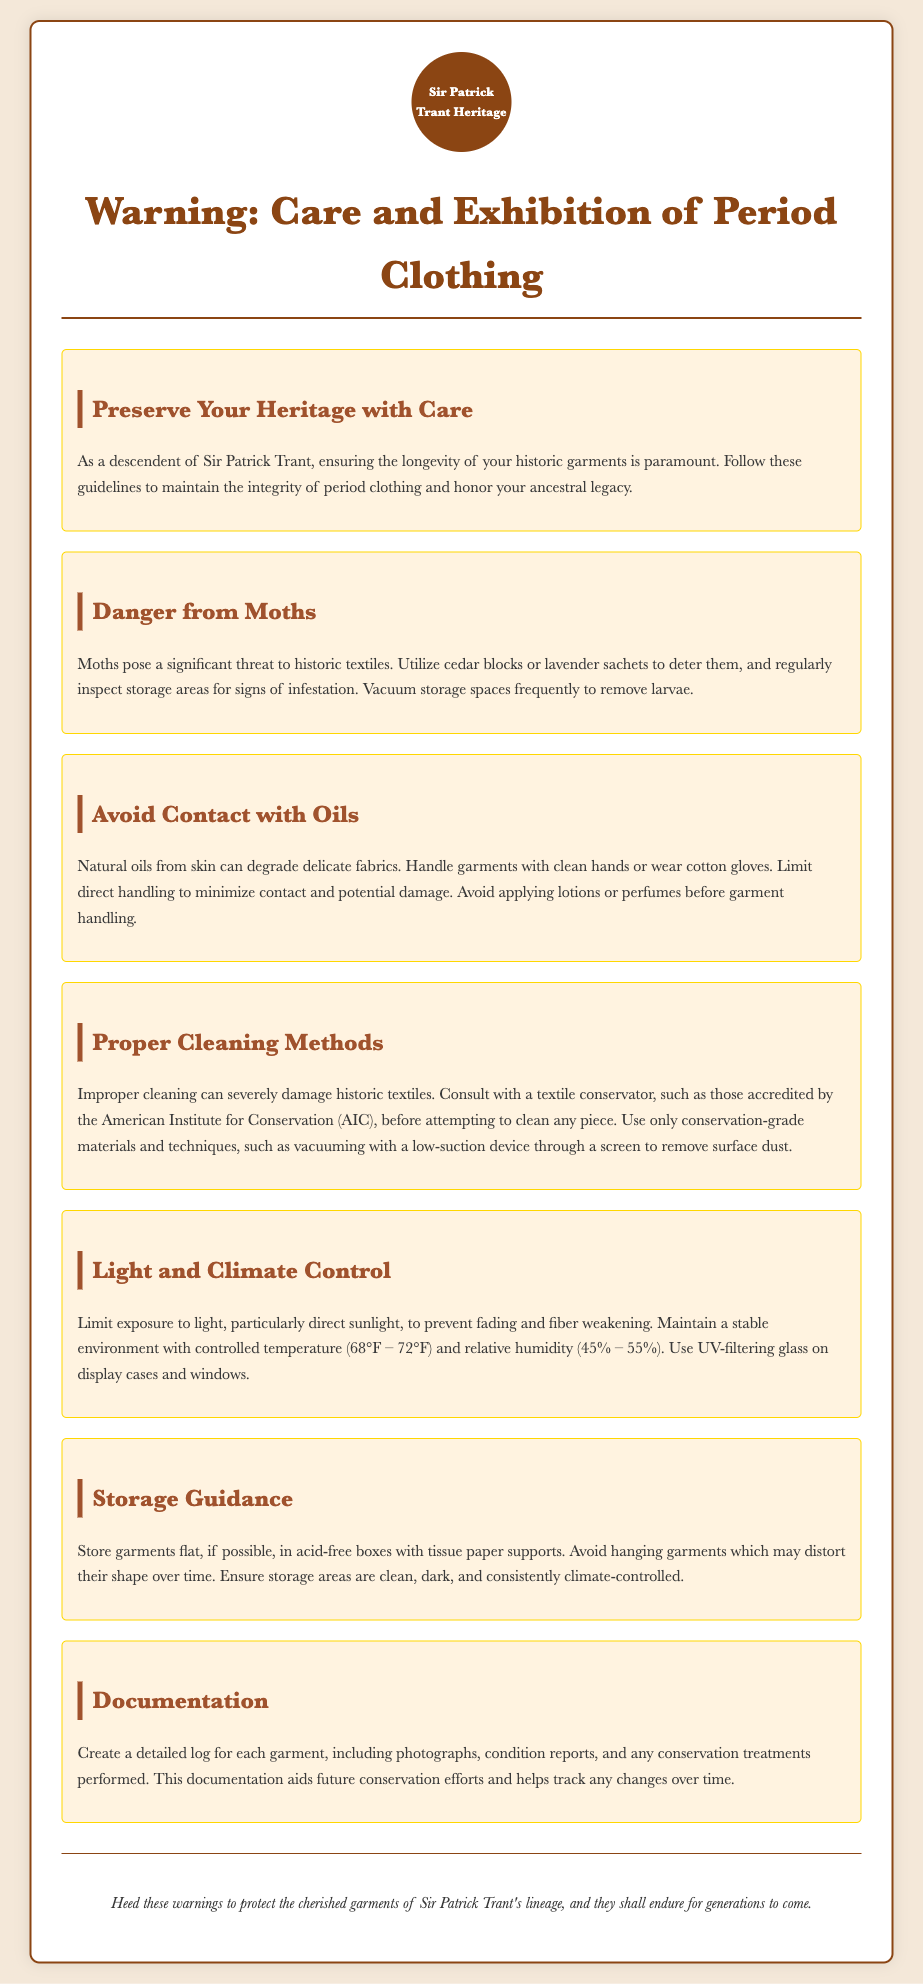What is the main purpose of the warning label? The warning label provides cautionary advice for the care and exhibition of period clothing.
Answer: Cautionary advice for the care and exhibition of period clothing What should be used to deter moths? The document suggests using cedar blocks or lavender sachets to deter moths.
Answer: Cedar blocks or lavender sachets What is the recommended storage condition for garments? The document states that storage areas should be clean, dark, and consistently climate-controlled.
Answer: Clean, dark, and consistently climate-controlled What temperature range is suggested for climate control? The document recommends maintaining a stable environment with a temperature of 68°F – 72°F.
Answer: 68°F – 72°F Who should be consulted for cleaning historic textiles? It is advised to consult with a textile conservator accredited by the American Institute for Conservation (AIC).
Answer: Textile conservator accredited by the AIC What should be avoided before handling garments? The document advises avoiding applying lotions or perfumes before handling garments.
Answer: Lotions or perfumes What should be documented for each garment? The document states that a detailed log including photographs, condition reports, and conservation treatments should be created.
Answer: Detailed log, photographs, condition reports, conservation treatments How often should storage spaces be vacuumed? The document recommends regularly vacuuming storage spaces to remove larvae.
Answer: Regularly 